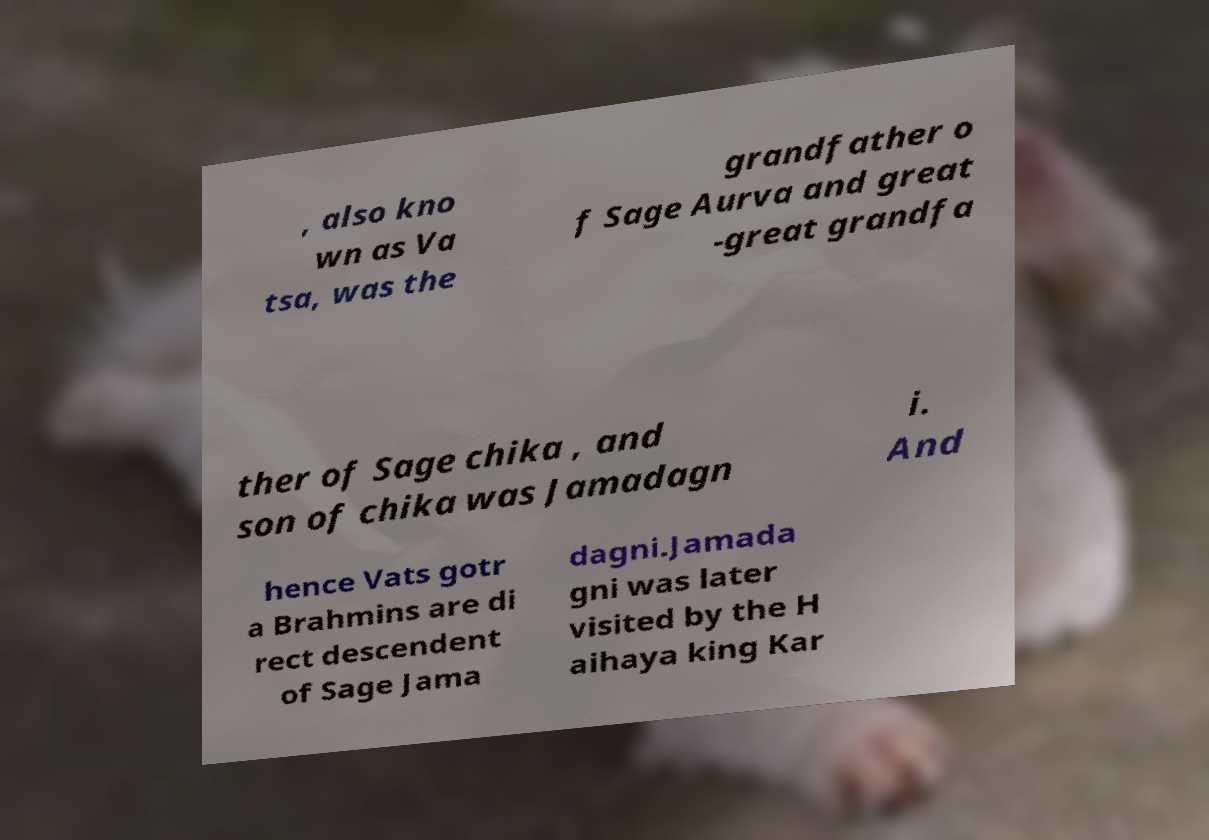Can you read and provide the text displayed in the image?This photo seems to have some interesting text. Can you extract and type it out for me? , also kno wn as Va tsa, was the grandfather o f Sage Aurva and great -great grandfa ther of Sage chika , and son of chika was Jamadagn i. And hence Vats gotr a Brahmins are di rect descendent of Sage Jama dagni.Jamada gni was later visited by the H aihaya king Kar 